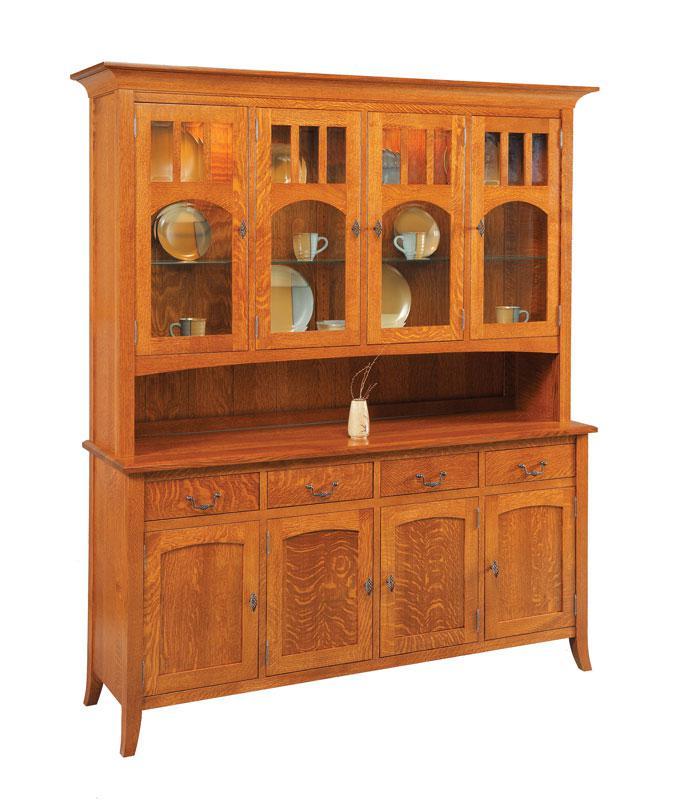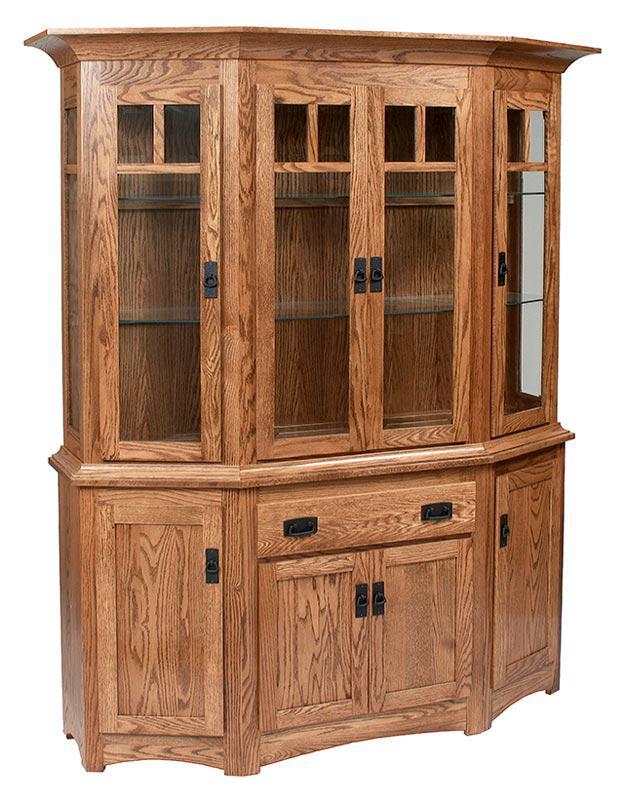The first image is the image on the left, the second image is the image on the right. Given the left and right images, does the statement "A brown wood cabinet has slender legs and arch shapes on the glass-fronted cabinet doors." hold true? Answer yes or no. Yes. The first image is the image on the left, the second image is the image on the right. Considering the images on both sides, is "A brown hutch is empty in the right image." valid? Answer yes or no. Yes. 